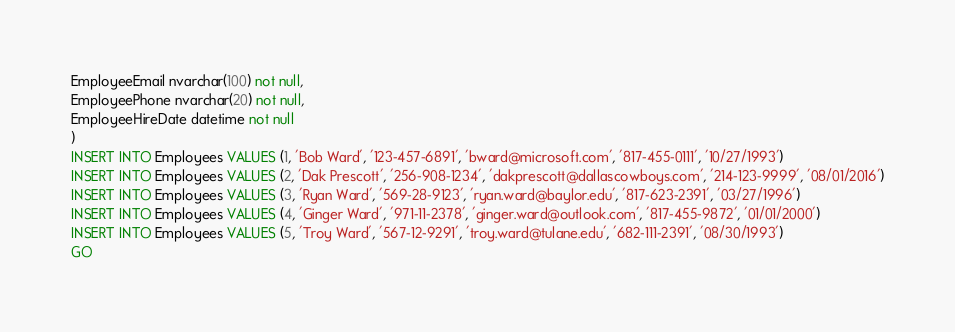Convert code to text. <code><loc_0><loc_0><loc_500><loc_500><_SQL_>EmployeeEmail nvarchar(100) not null,
EmployeePhone nvarchar(20) not null,
EmployeeHireDate datetime not null
)
INSERT INTO Employees VALUES (1, 'Bob Ward', '123-457-6891', 'bward@microsoft.com', '817-455-0111', '10/27/1993')
INSERT INTO Employees VALUES (2, 'Dak Prescott', '256-908-1234', 'dakprescott@dallascowboys.com', '214-123-9999', '08/01/2016')
INSERT INTO Employees VALUES (3, 'Ryan Ward', '569-28-9123', 'ryan.ward@baylor.edu', '817-623-2391', '03/27/1996')
INSERT INTO Employees VALUES (4, 'Ginger Ward', '971-11-2378', 'ginger.ward@outlook.com', '817-455-9872', '01/01/2000')
INSERT INTO Employees VALUES (5, 'Troy Ward', '567-12-9291', 'troy.ward@tulane.edu', '682-111-2391', '08/30/1993')
GO</code> 